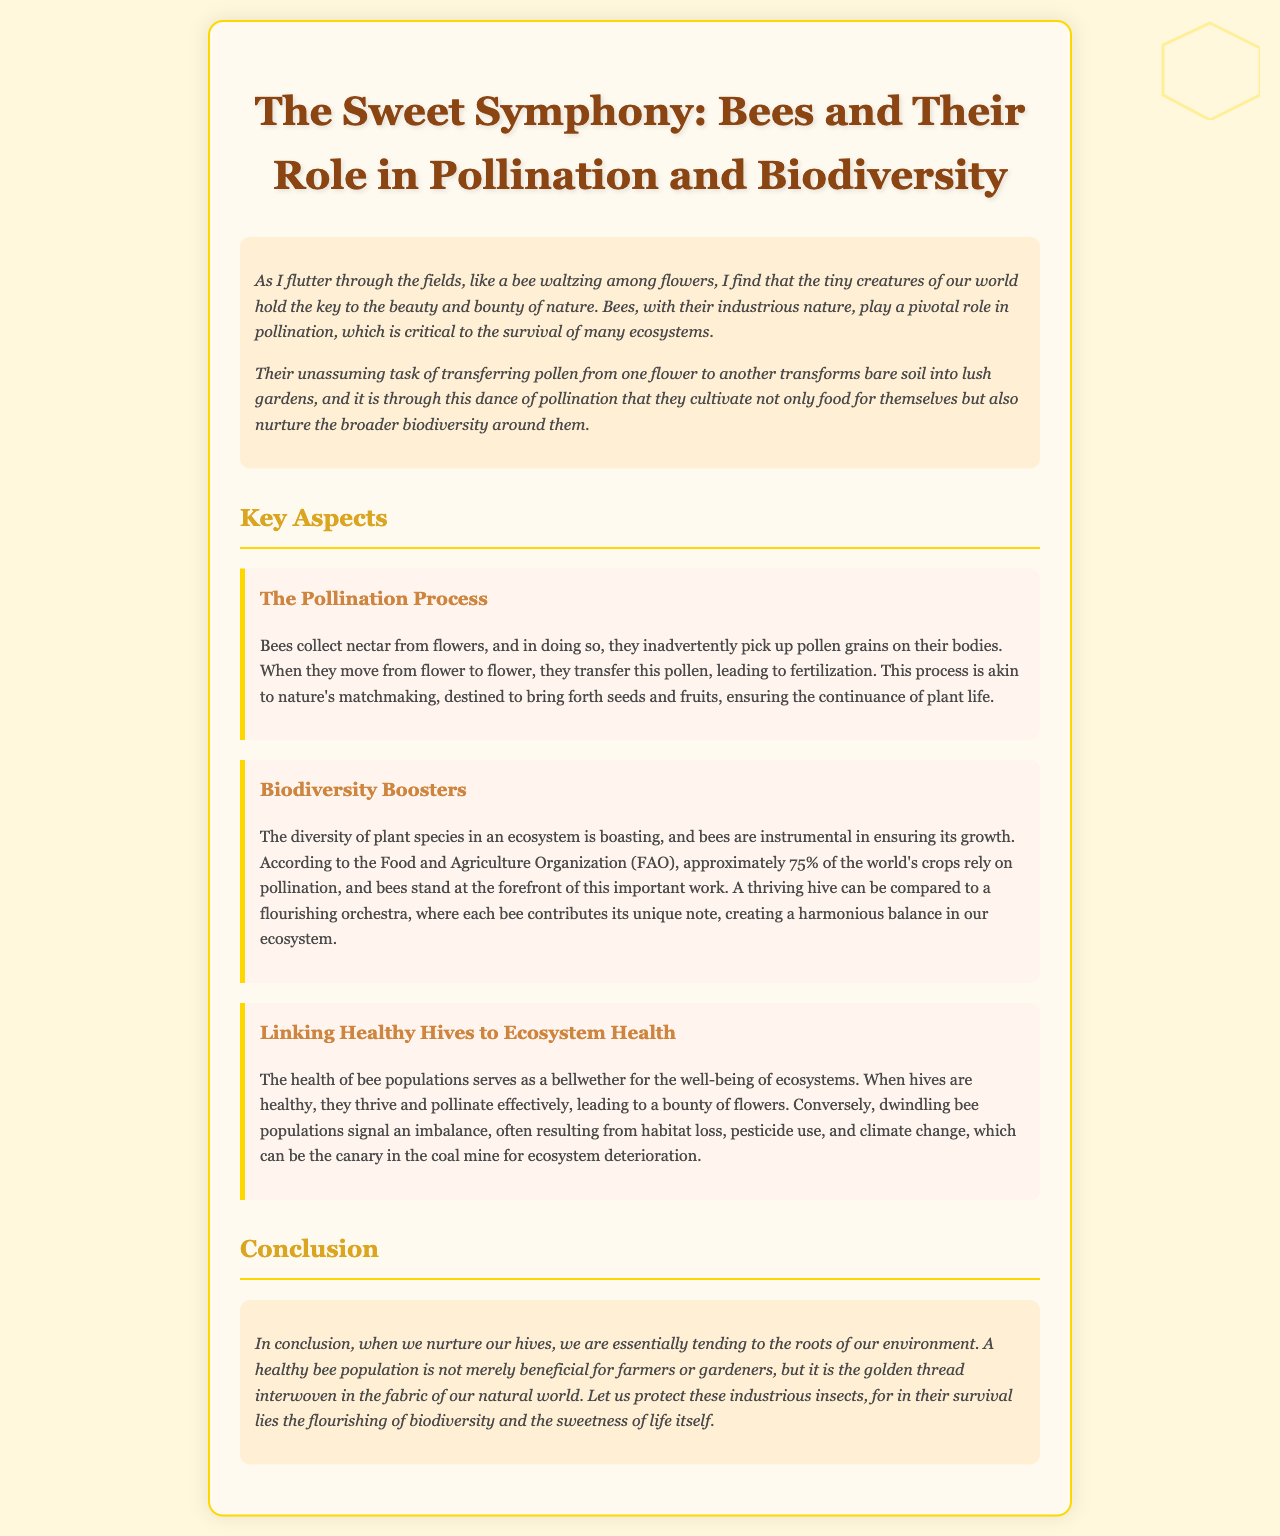What is the title of the report? The title is stated at the top of the document, reflecting its central theme.
Answer: The Sweet Symphony: Bees and Their Role in Pollination and Biodiversity What role do bees play in ecosystems? The report discusses the important function of bees in pollination and biodiversity.
Answer: Pollination What percentage of the world's crops rely on pollination? This percentage is mentioned in a key aspect that highlights the importance of bees.
Answer: 75% What does a healthy hive resemble according to the text? The document uses a metaphor to describe the harmony within a healthy bee population.
Answer: A flourishing orchestra What can declining bee populations indicate? The link between bee health and ecosystem health is explained, revealing what bee population decline signifies.
Answer: Ecosystem deterioration What is the overarching theme of the conclusion? The conclusion summarizes the importance of bee populations in relation to the environment.
Answer: Nurturing our hives How does the document describe the process of pollination? An explanation of the process is given in terms of its impact on plant reproduction.
Answer: Nature's matchmaking What aspects can negatively affect bee populations? The report lists factors impacting bees and, consequently, ecosystems.
Answer: Habitat loss, pesticide use, and climate change 